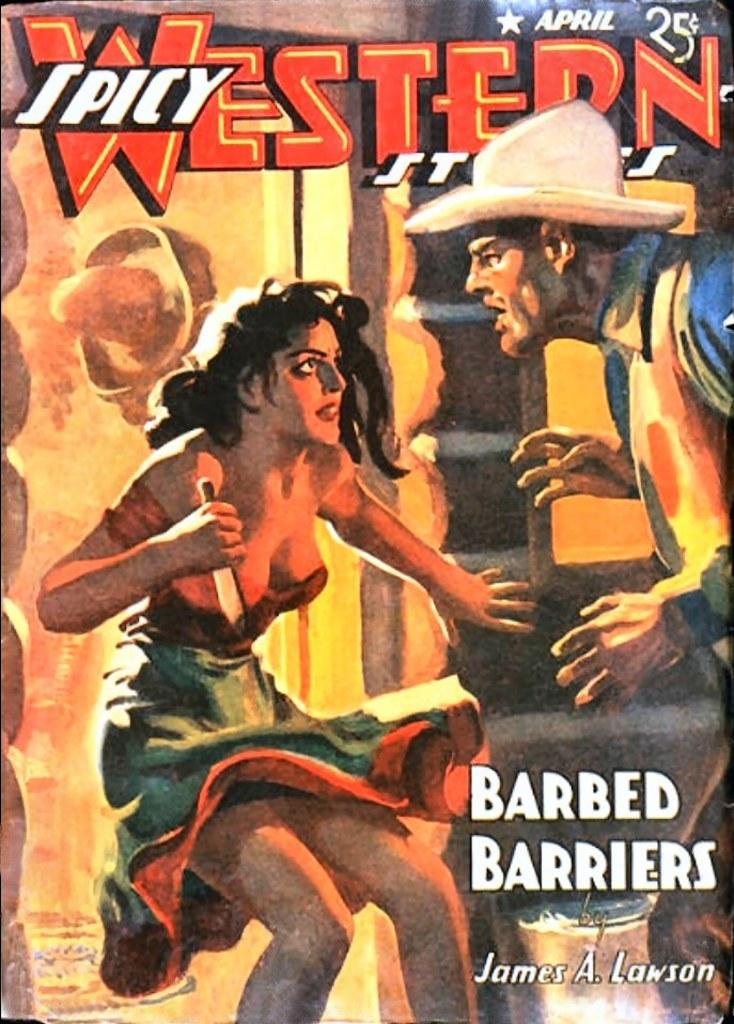Could you give a brief overview of what you see in this image? In this image I can see the cover page of the book in which I can see a woman holding a knife and a man. I can see something is written on the cover page. 